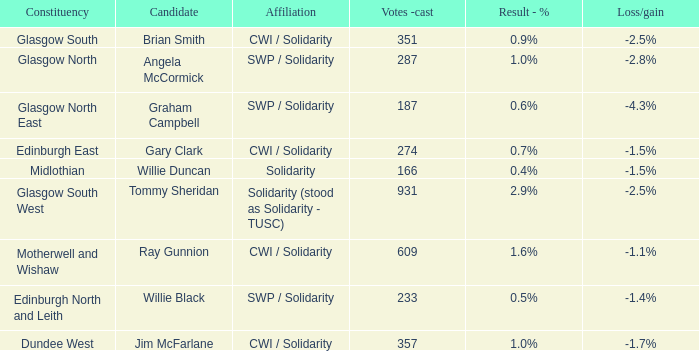What was the loss/gain when the votes -cast was 166? -1.5%. 